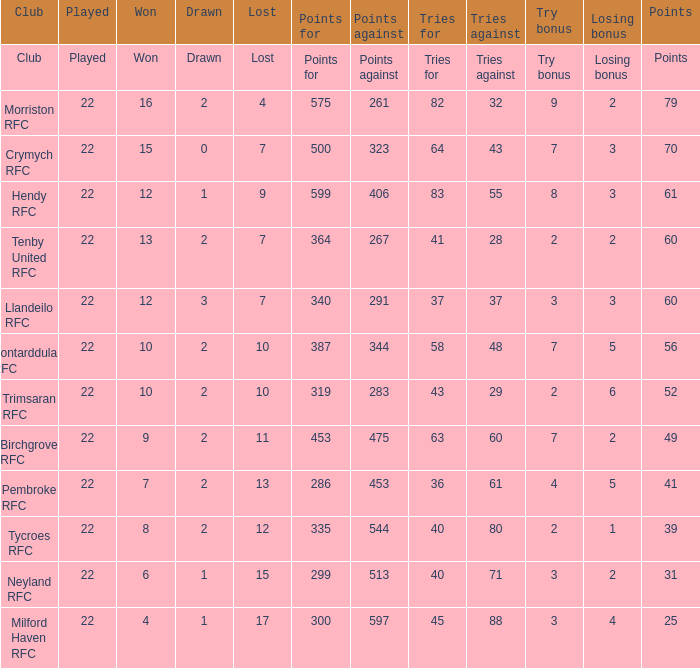What's the success with an effort bonus of 8? 12.0. 